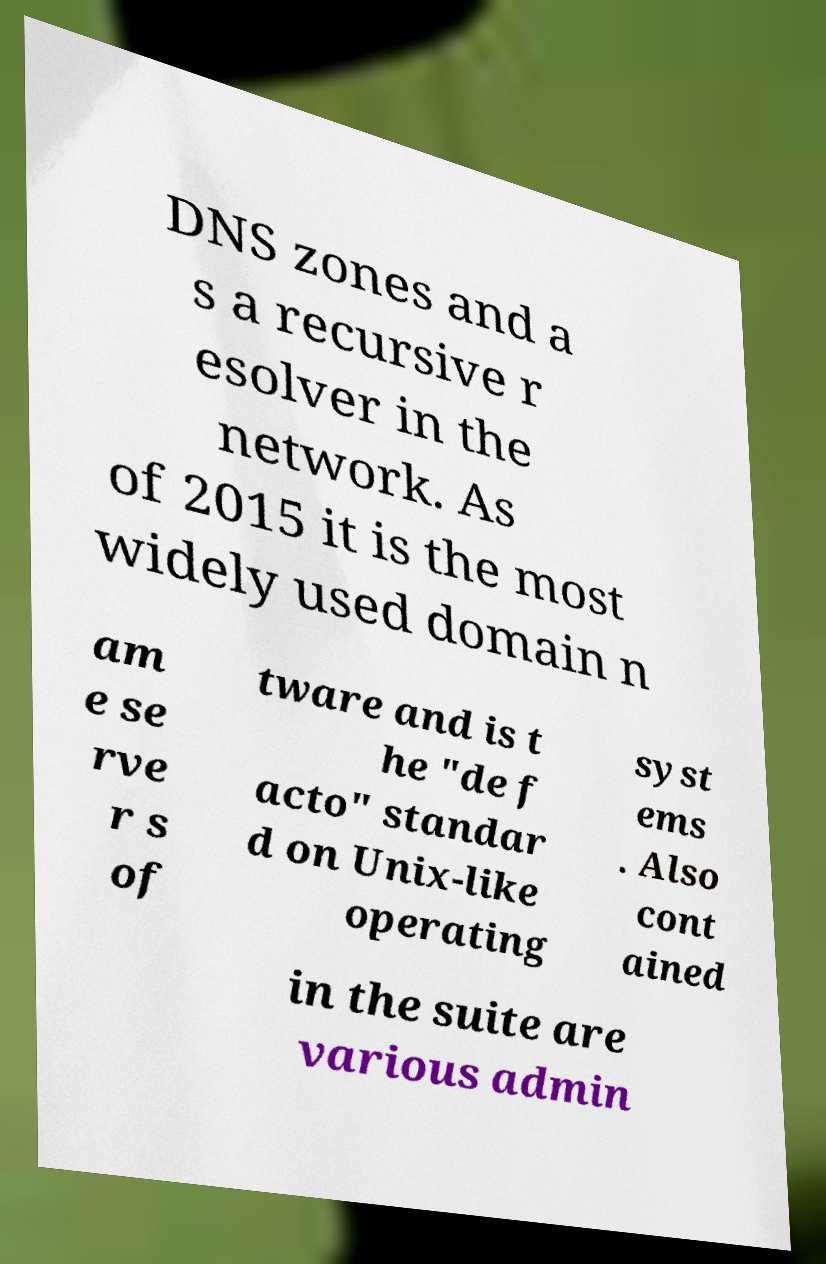Please read and relay the text visible in this image. What does it say? DNS zones and a s a recursive r esolver in the network. As of 2015 it is the most widely used domain n am e se rve r s of tware and is t he "de f acto" standar d on Unix-like operating syst ems . Also cont ained in the suite are various admin 